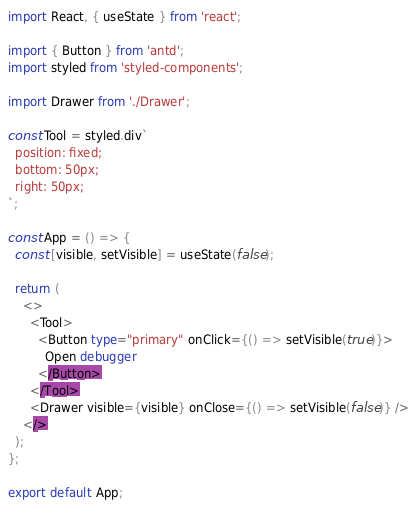Convert code to text. <code><loc_0><loc_0><loc_500><loc_500><_TypeScript_>import React, { useState } from 'react';

import { Button } from 'antd';
import styled from 'styled-components';

import Drawer from './Drawer';

const Tool = styled.div`
  position: fixed;
  bottom: 50px;
  right: 50px;
`;

const App = () => {
  const [visible, setVisible] = useState(false);

  return (
    <>
      <Tool>
        <Button type="primary" onClick={() => setVisible(true)}>
          Open debugger
        </Button>
      </Tool>
      <Drawer visible={visible} onClose={() => setVisible(false)} />
    </>
  );
};

export default App;
</code> 